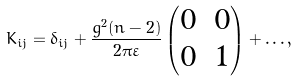Convert formula to latex. <formula><loc_0><loc_0><loc_500><loc_500>K _ { i j } = \delta _ { i j } + \frac { g ^ { 2 } ( n - 2 ) } { 2 \pi \varepsilon } \begin{pmatrix} 0 & 0 \\ 0 & 1 \end{pmatrix} + \dots ,</formula> 